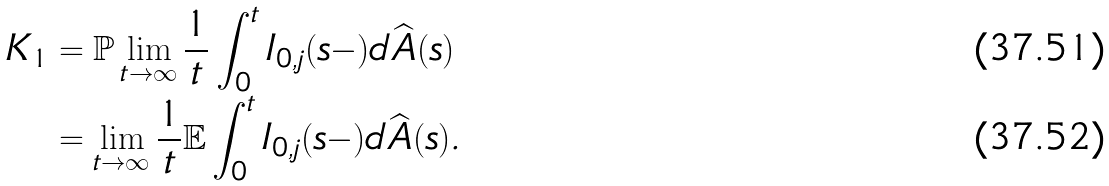Convert formula to latex. <formula><loc_0><loc_0><loc_500><loc_500>K _ { 1 } & = \mathbb { P } \lim _ { t \to \infty } \frac { 1 } { t } \int _ { 0 } ^ { t } I _ { 0 , j } ( s - ) d \widehat { A } ( s ) \\ & = \lim _ { t \to \infty } \frac { 1 } { t } \mathbb { E } \int _ { 0 } ^ { t } I _ { 0 , j } ( s - ) d \widehat { A } ( s ) .</formula> 